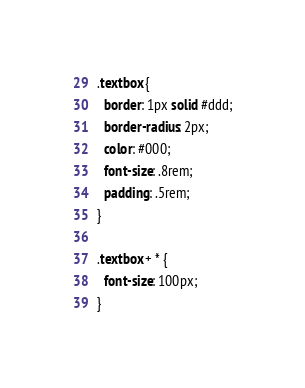<code> <loc_0><loc_0><loc_500><loc_500><_CSS_>.textbox {
  border: 1px solid #ddd;
  border-radius: 2px;
  color: #000;
  font-size: .8rem;
  padding: .5rem;
}

.textbox + * {
  font-size: 100px;
}
</code> 